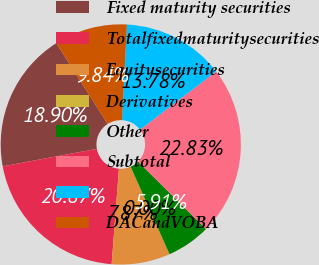Convert chart to OTSL. <chart><loc_0><loc_0><loc_500><loc_500><pie_chart><fcel>Fixed maturity securities<fcel>Totalfixedmaturitysecurities<fcel>Equitysecurities<fcel>Derivatives<fcel>Other<fcel>Subtotal<fcel>Unnamed: 6<fcel>DACandVOBA<nl><fcel>18.9%<fcel>20.87%<fcel>7.87%<fcel>0.0%<fcel>5.91%<fcel>22.83%<fcel>13.78%<fcel>9.84%<nl></chart> 